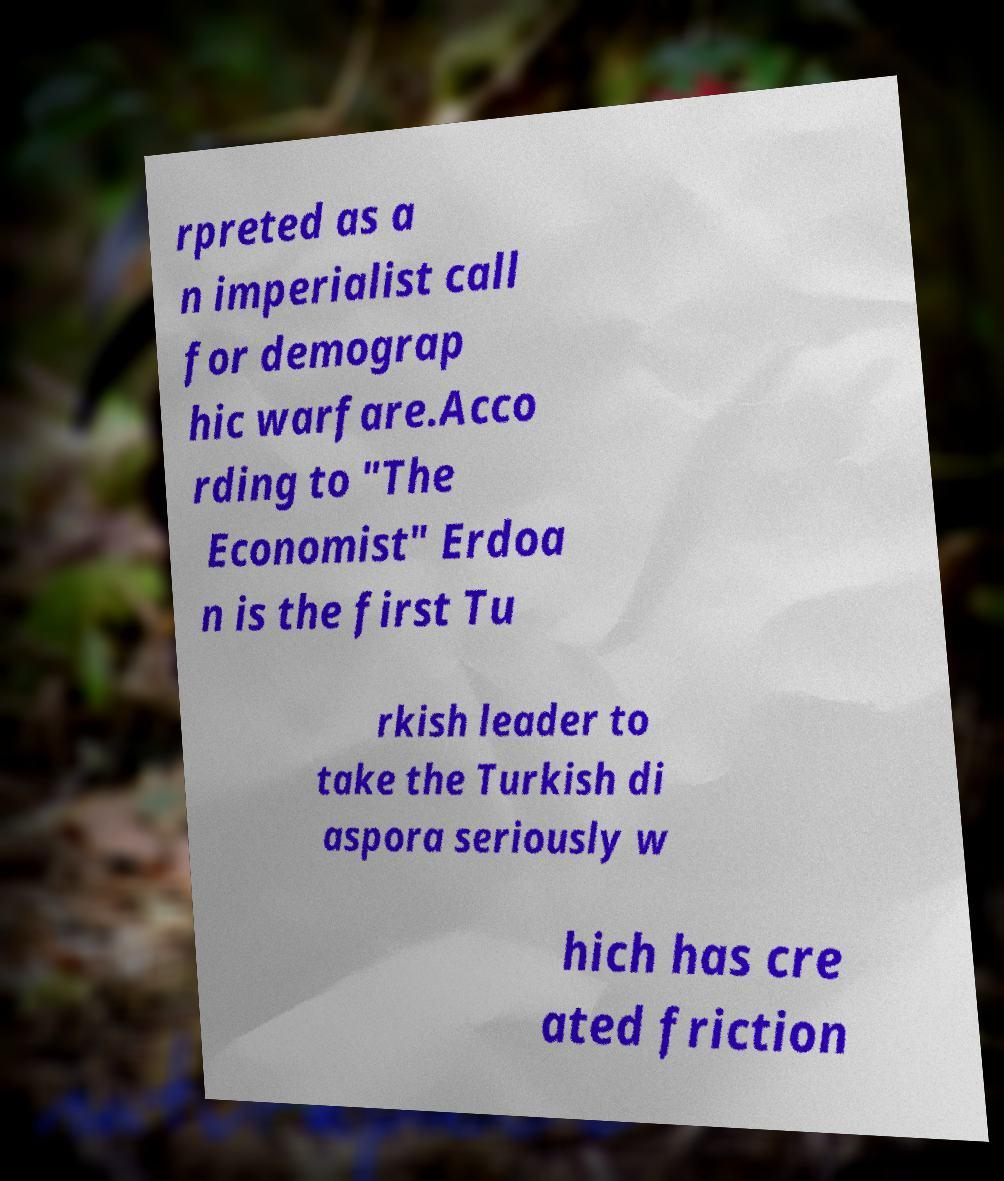Can you read and provide the text displayed in the image?This photo seems to have some interesting text. Can you extract and type it out for me? rpreted as a n imperialist call for demograp hic warfare.Acco rding to "The Economist" Erdoa n is the first Tu rkish leader to take the Turkish di aspora seriously w hich has cre ated friction 